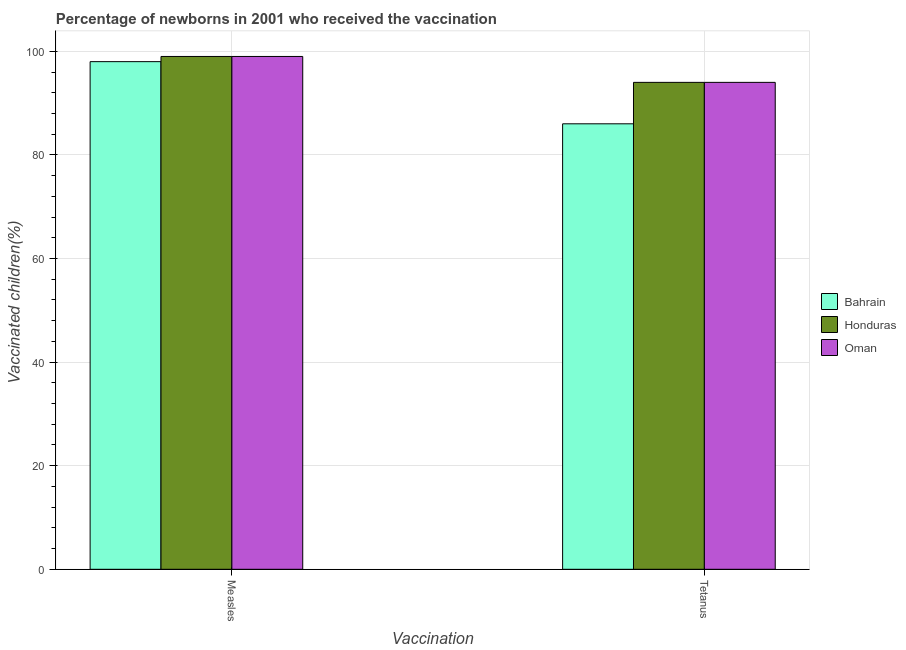Are the number of bars per tick equal to the number of legend labels?
Your answer should be compact. Yes. How many bars are there on the 2nd tick from the right?
Offer a very short reply. 3. What is the label of the 2nd group of bars from the left?
Give a very brief answer. Tetanus. What is the percentage of newborns who received vaccination for measles in Bahrain?
Keep it short and to the point. 98. Across all countries, what is the maximum percentage of newborns who received vaccination for tetanus?
Give a very brief answer. 94. Across all countries, what is the minimum percentage of newborns who received vaccination for tetanus?
Your answer should be very brief. 86. In which country was the percentage of newborns who received vaccination for tetanus maximum?
Ensure brevity in your answer.  Honduras. In which country was the percentage of newborns who received vaccination for tetanus minimum?
Ensure brevity in your answer.  Bahrain. What is the total percentage of newborns who received vaccination for tetanus in the graph?
Give a very brief answer. 274. What is the difference between the percentage of newborns who received vaccination for tetanus in Oman and that in Bahrain?
Offer a very short reply. 8. What is the difference between the percentage of newborns who received vaccination for measles in Honduras and the percentage of newborns who received vaccination for tetanus in Bahrain?
Give a very brief answer. 13. What is the average percentage of newborns who received vaccination for measles per country?
Keep it short and to the point. 98.67. What is the difference between the percentage of newborns who received vaccination for measles and percentage of newborns who received vaccination for tetanus in Bahrain?
Your answer should be compact. 12. What is the ratio of the percentage of newborns who received vaccination for measles in Bahrain to that in Honduras?
Give a very brief answer. 0.99. Is the percentage of newborns who received vaccination for tetanus in Oman less than that in Honduras?
Offer a very short reply. No. What does the 1st bar from the left in Measles represents?
Make the answer very short. Bahrain. What does the 3rd bar from the right in Measles represents?
Your response must be concise. Bahrain. How many bars are there?
Make the answer very short. 6. Are all the bars in the graph horizontal?
Provide a short and direct response. No. How many countries are there in the graph?
Offer a very short reply. 3. Are the values on the major ticks of Y-axis written in scientific E-notation?
Give a very brief answer. No. Does the graph contain any zero values?
Ensure brevity in your answer.  No. Does the graph contain grids?
Make the answer very short. Yes. Where does the legend appear in the graph?
Keep it short and to the point. Center right. What is the title of the graph?
Provide a succinct answer. Percentage of newborns in 2001 who received the vaccination. Does "Haiti" appear as one of the legend labels in the graph?
Your answer should be very brief. No. What is the label or title of the X-axis?
Give a very brief answer. Vaccination. What is the label or title of the Y-axis?
Keep it short and to the point. Vaccinated children(%)
. What is the Vaccinated children(%)
 of Honduras in Measles?
Keep it short and to the point. 99. What is the Vaccinated children(%)
 in Honduras in Tetanus?
Provide a short and direct response. 94. What is the Vaccinated children(%)
 of Oman in Tetanus?
Your answer should be very brief. 94. Across all Vaccination, what is the maximum Vaccinated children(%)
 of Bahrain?
Your answer should be compact. 98. Across all Vaccination, what is the maximum Vaccinated children(%)
 in Oman?
Make the answer very short. 99. Across all Vaccination, what is the minimum Vaccinated children(%)
 of Honduras?
Your response must be concise. 94. Across all Vaccination, what is the minimum Vaccinated children(%)
 of Oman?
Provide a succinct answer. 94. What is the total Vaccinated children(%)
 of Bahrain in the graph?
Give a very brief answer. 184. What is the total Vaccinated children(%)
 in Honduras in the graph?
Provide a short and direct response. 193. What is the total Vaccinated children(%)
 of Oman in the graph?
Provide a succinct answer. 193. What is the average Vaccinated children(%)
 in Bahrain per Vaccination?
Make the answer very short. 92. What is the average Vaccinated children(%)
 of Honduras per Vaccination?
Your answer should be compact. 96.5. What is the average Vaccinated children(%)
 in Oman per Vaccination?
Ensure brevity in your answer.  96.5. What is the difference between the Vaccinated children(%)
 of Bahrain and Vaccinated children(%)
 of Honduras in Measles?
Provide a short and direct response. -1. What is the difference between the Vaccinated children(%)
 in Bahrain and Vaccinated children(%)
 in Honduras in Tetanus?
Provide a short and direct response. -8. What is the difference between the Vaccinated children(%)
 of Honduras and Vaccinated children(%)
 of Oman in Tetanus?
Offer a very short reply. 0. What is the ratio of the Vaccinated children(%)
 of Bahrain in Measles to that in Tetanus?
Keep it short and to the point. 1.14. What is the ratio of the Vaccinated children(%)
 of Honduras in Measles to that in Tetanus?
Provide a succinct answer. 1.05. What is the ratio of the Vaccinated children(%)
 of Oman in Measles to that in Tetanus?
Offer a terse response. 1.05. What is the difference between the highest and the second highest Vaccinated children(%)
 of Bahrain?
Your response must be concise. 12. What is the difference between the highest and the second highest Vaccinated children(%)
 in Honduras?
Offer a terse response. 5. What is the difference between the highest and the second highest Vaccinated children(%)
 of Oman?
Ensure brevity in your answer.  5. What is the difference between the highest and the lowest Vaccinated children(%)
 in Bahrain?
Keep it short and to the point. 12. What is the difference between the highest and the lowest Vaccinated children(%)
 of Honduras?
Offer a terse response. 5. 